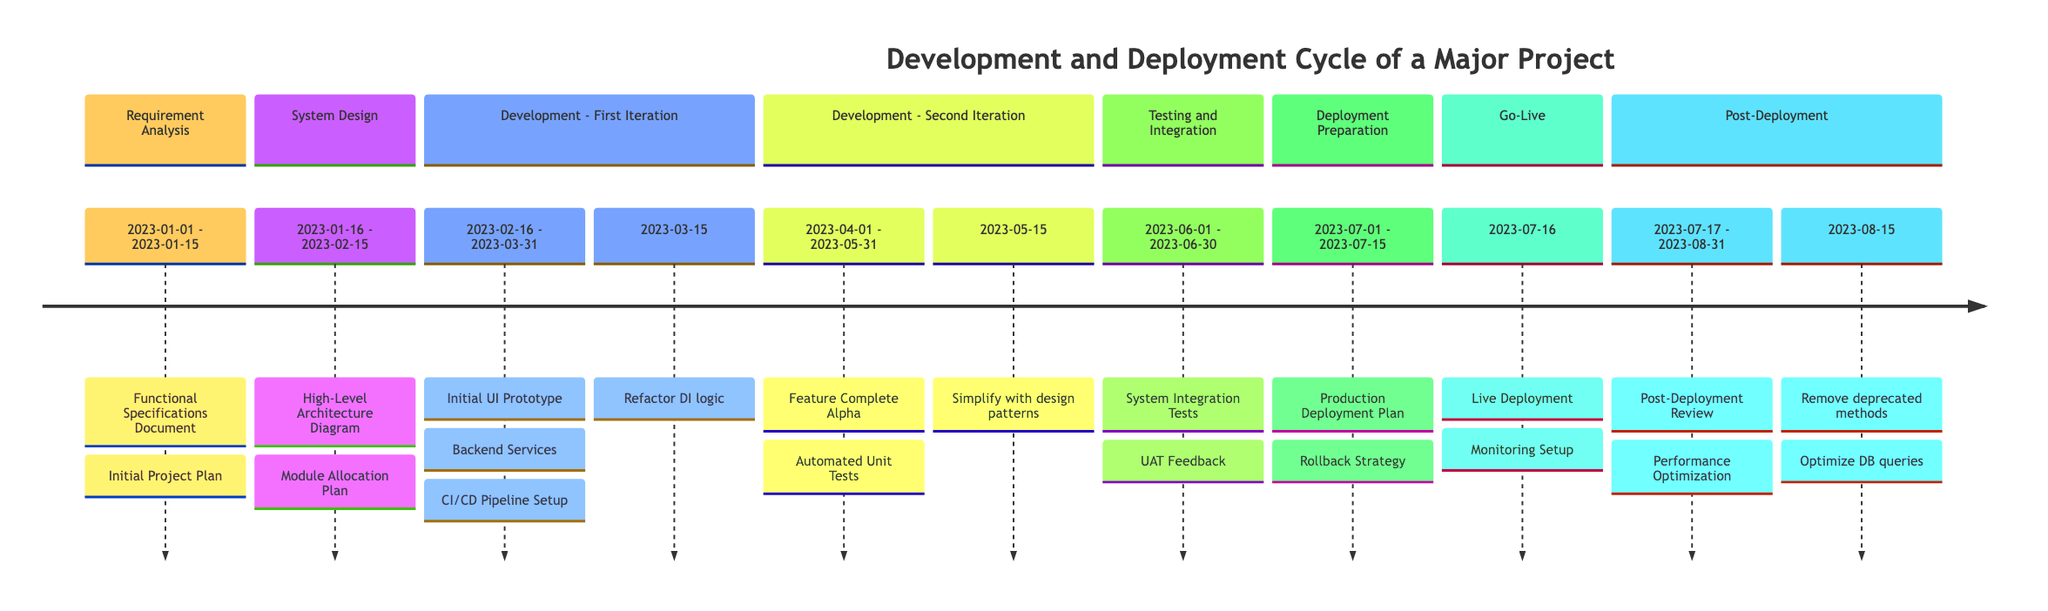What is the duration of the Requirement Analysis phase? The Requirement Analysis phase starts on January 1, 2023, and ends on January 15, 2023. Calculating the duration gives 15 days.
Answer: 15 days Which deliverable is produced at the end of the Development - First Iteration phase? In the Development - First Iteration phase, the deliverables include "Initial UI Prototype," "Backend Services with decoupled Business Logic," and "CI/CD Pipeline Setup." The first one is "Initial UI Prototype."
Answer: Initial UI Prototype How many phases include refactorings? The timeline indicates refactorings only in the Development - First Iteration and Post-Deployment phases. There are a total of 2 phases with refactorings.
Answer: 2 phases What is the start date of the Deployment Preparation phase? The Deployment Preparation phase starts on July 1, 2023. This information is explicitly stated in the timeline's breakdown of phases.
Answer: July 1, 2023 Which deliverable comes immediately after the Go-Live phase? The Go-Live phase is followed by the Post-Deployment phase, which includes the deliverables "Post-Deployment Review" and "Performance Optimization." Therefore, the first deliverable in this phase is "Post-Deployment Review."
Answer: Post-Deployment Review What deliverable corresponds to the Testing and Integration phase? The Testing and Integration phase has two deliverables listed: "System Integration Tests" and "User Acceptance Testing Feedback." Therefore, these are the deliverables produced during this phase.
Answer: System Integration Tests What is the latest possible end date among all project phases? The last phase is Post-Deployment, which ends on August 31, 2023. This is confirmed by looking at the endpoint of the last phase in the timeline.
Answer: August 31, 2023 Which refactoring aims to optimize the database queries? The refactoring related to database optimization is specifically listed under the Post-Deployment phase and is labeled as "Optimize database queries."
Answer: Optimize database queries 